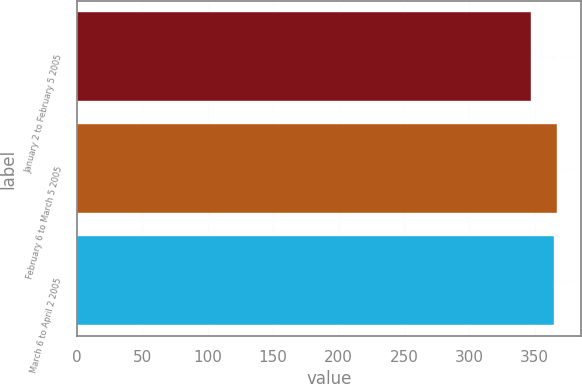Convert chart. <chart><loc_0><loc_0><loc_500><loc_500><bar_chart><fcel>January 2 to February 5 2005<fcel>February 6 to March 5 2005<fcel>March 6 to April 2 2005<nl><fcel>347<fcel>367<fcel>365<nl></chart> 